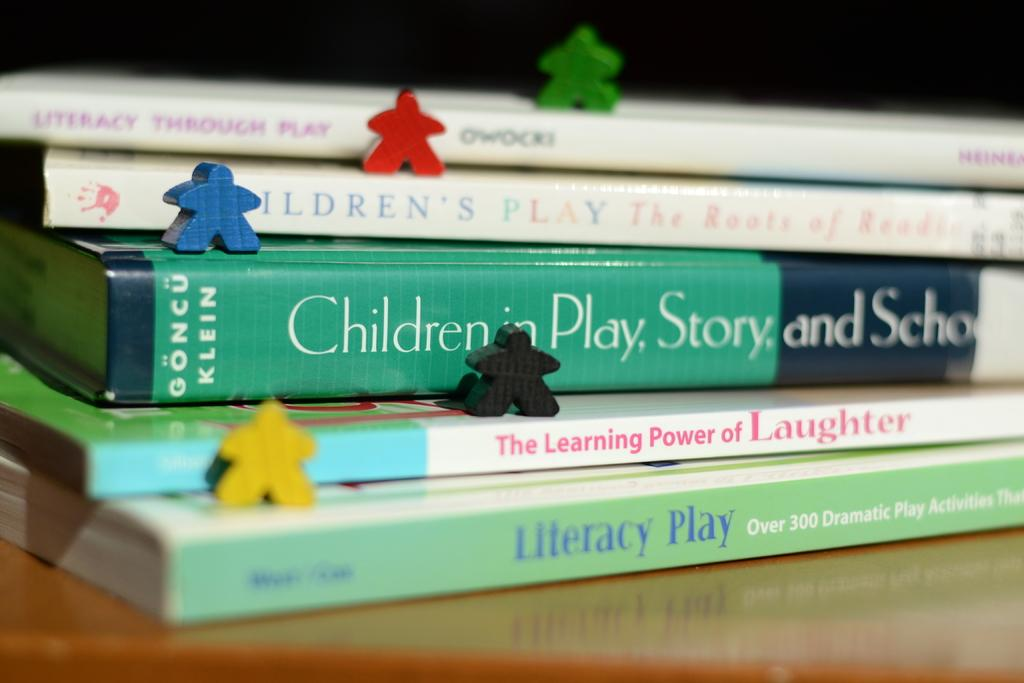<image>
Write a terse but informative summary of the picture. a few books that have literacy written on one 